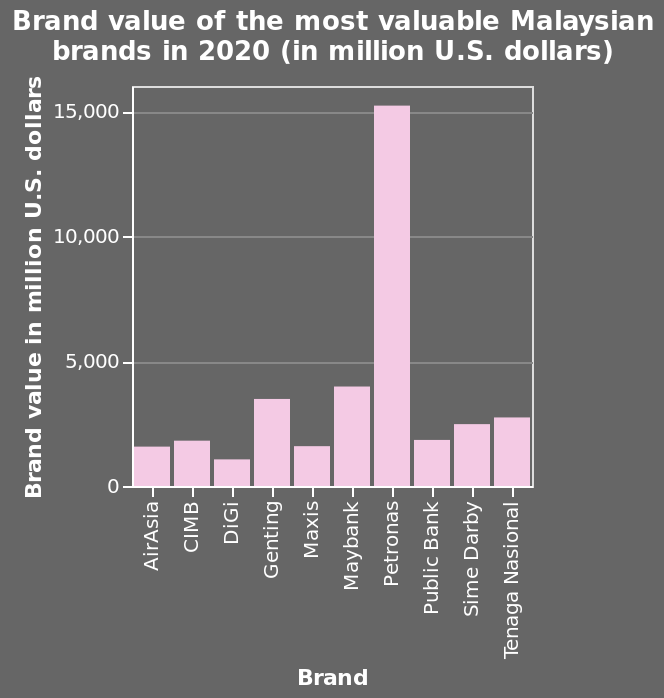<image>
please enumerates aspects of the construction of the chart Here a bar chart is named Brand value of the most valuable Malaysian brands in 2020 (in million U.S. dollars). The x-axis shows Brand on categorical scale with AirAsia on one end and Tenaga Nasional at the other while the y-axis shows Brand value in million U.S. dollars as linear scale of range 0 to 15,000. What is the approximate average value mentioned in the figure?  The average value appears to be around 2500. 